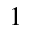Convert formula to latex. <formula><loc_0><loc_0><loc_500><loc_500>^ { 1 }</formula> 